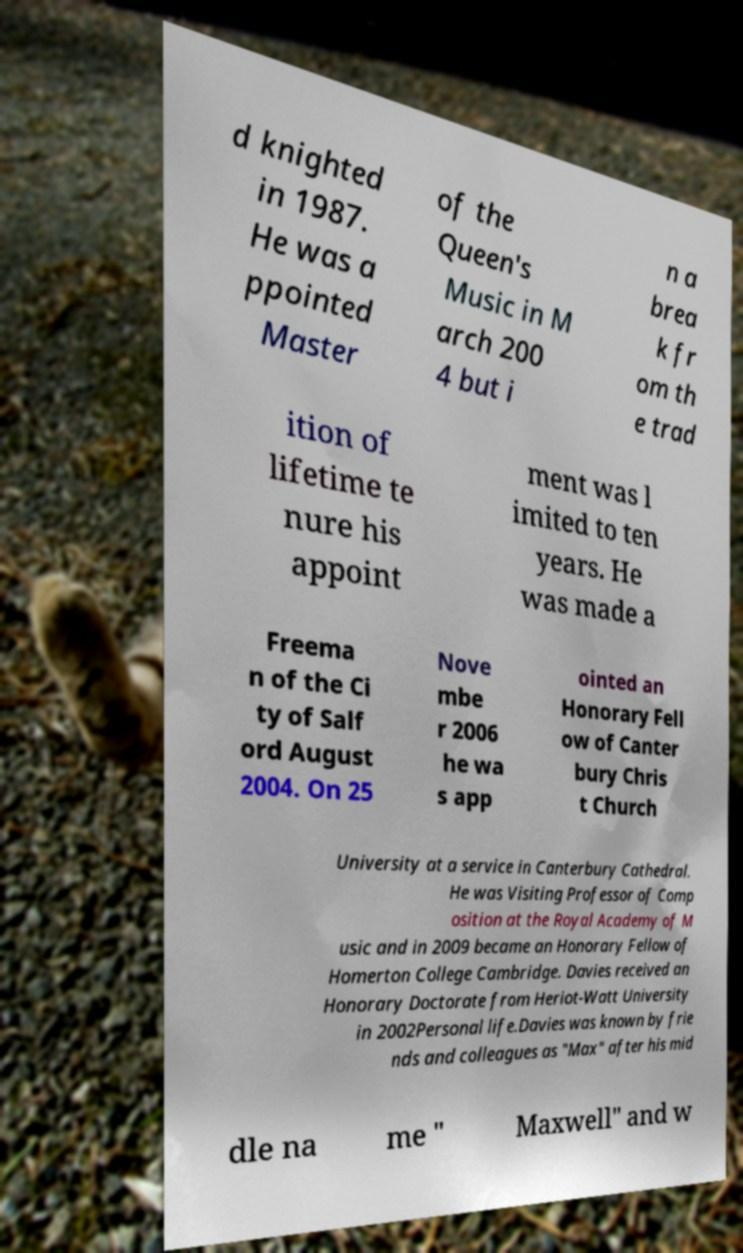Could you extract and type out the text from this image? d knighted in 1987. He was a ppointed Master of the Queen's Music in M arch 200 4 but i n a brea k fr om th e trad ition of lifetime te nure his appoint ment was l imited to ten years. He was made a Freema n of the Ci ty of Salf ord August 2004. On 25 Nove mbe r 2006 he wa s app ointed an Honorary Fell ow of Canter bury Chris t Church University at a service in Canterbury Cathedral. He was Visiting Professor of Comp osition at the Royal Academy of M usic and in 2009 became an Honorary Fellow of Homerton College Cambridge. Davies received an Honorary Doctorate from Heriot-Watt University in 2002Personal life.Davies was known by frie nds and colleagues as "Max" after his mid dle na me " Maxwell" and w 